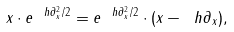<formula> <loc_0><loc_0><loc_500><loc_500>x \cdot e ^ { \ h \partial _ { x } ^ { 2 } / 2 } = e ^ { \ h \partial _ { x } ^ { 2 } / 2 } \cdot ( x - \ h \partial _ { x } ) ,</formula> 